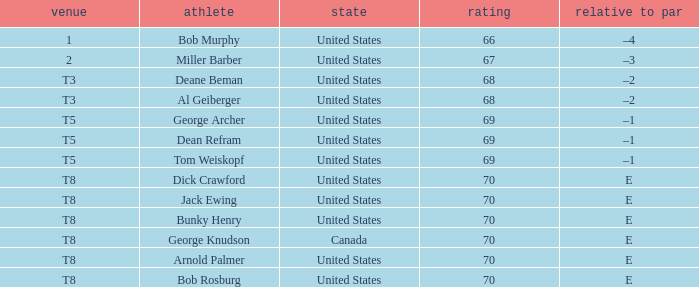When bunky henry secured t8, what was his to par? E. 